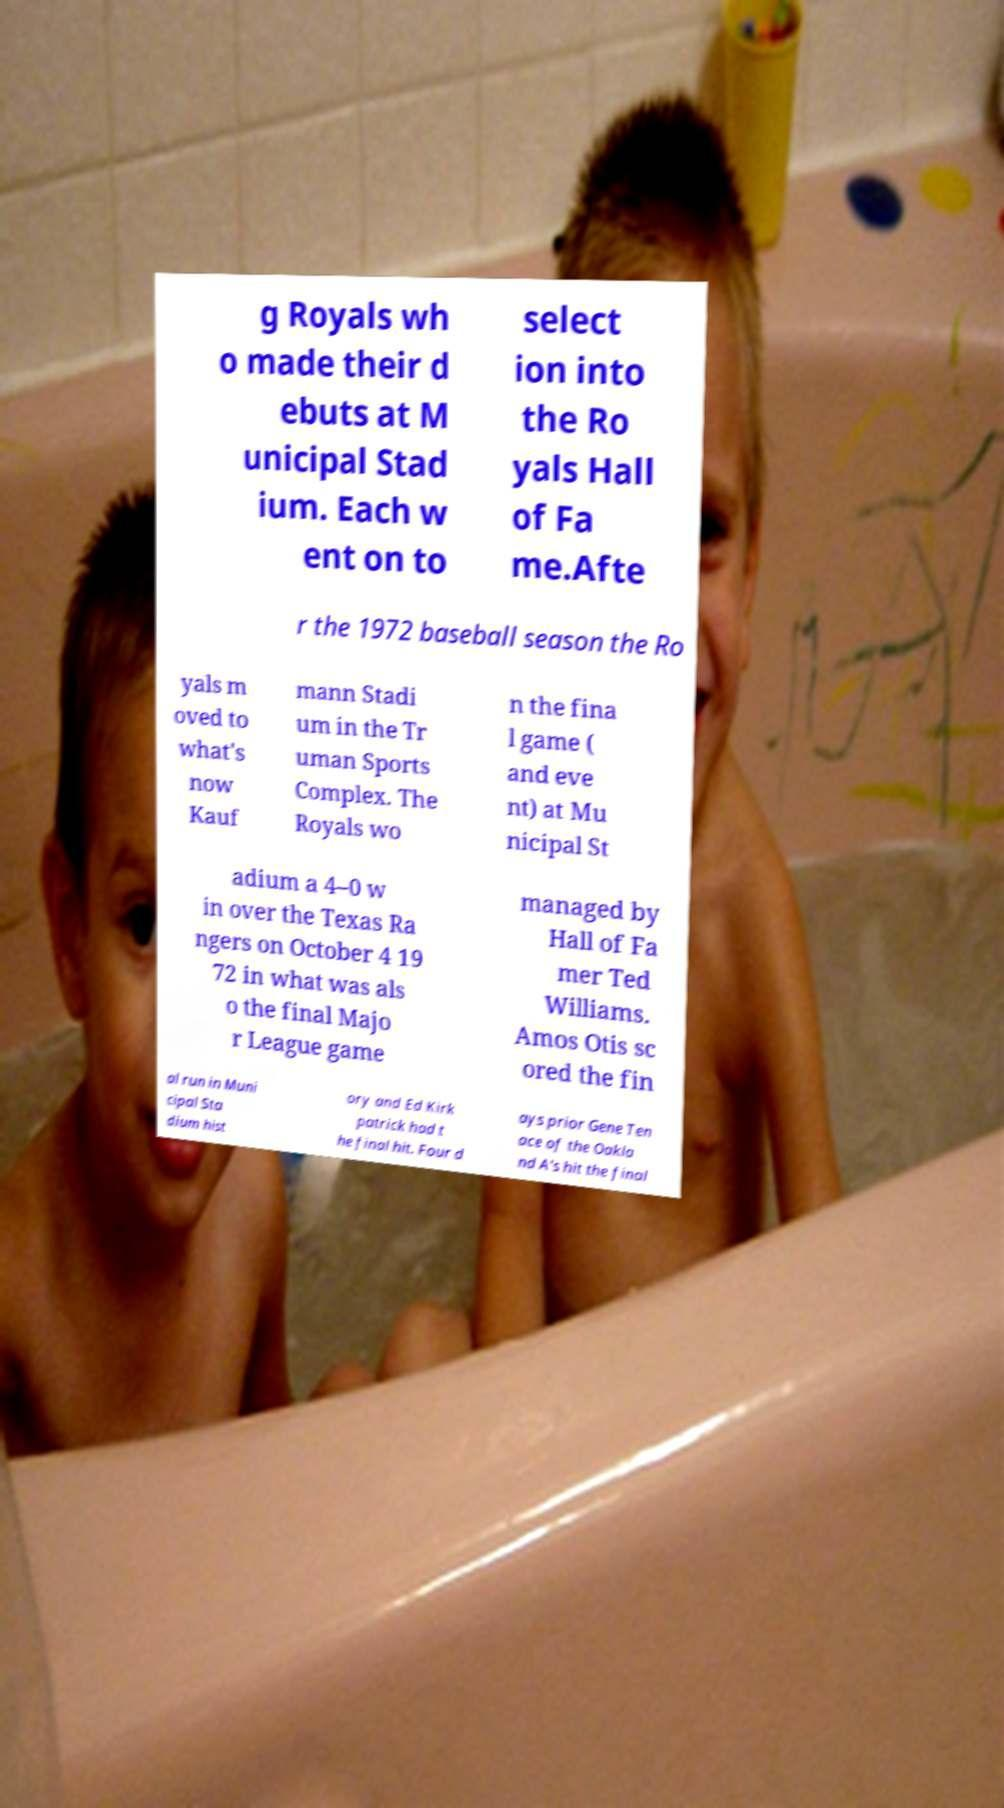There's text embedded in this image that I need extracted. Can you transcribe it verbatim? g Royals wh o made their d ebuts at M unicipal Stad ium. Each w ent on to select ion into the Ro yals Hall of Fa me.Afte r the 1972 baseball season the Ro yals m oved to what's now Kauf mann Stadi um in the Tr uman Sports Complex. The Royals wo n the fina l game ( and eve nt) at Mu nicipal St adium a 4–0 w in over the Texas Ra ngers on October 4 19 72 in what was als o the final Majo r League game managed by Hall of Fa mer Ted Williams. Amos Otis sc ored the fin al run in Muni cipal Sta dium hist ory and Ed Kirk patrick had t he final hit. Four d ays prior Gene Ten ace of the Oakla nd A's hit the final 